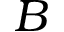<formula> <loc_0><loc_0><loc_500><loc_500>B</formula> 